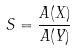Convert formula to latex. <formula><loc_0><loc_0><loc_500><loc_500>S = \frac { A ( X ) } { A ( Y ) }</formula> 